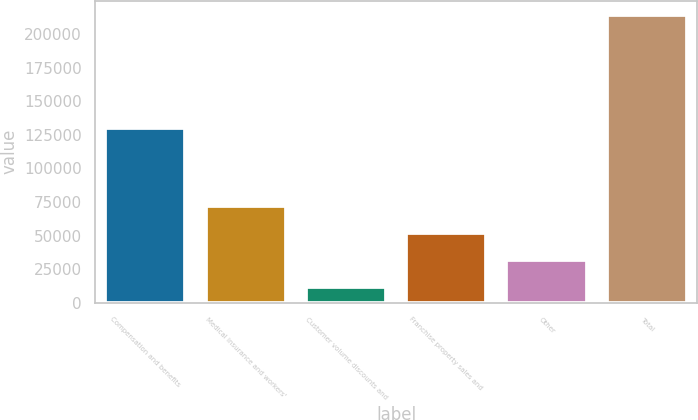<chart> <loc_0><loc_0><loc_500><loc_500><bar_chart><fcel>Compensation and benefits<fcel>Medical insurance and workers'<fcel>Customer volume discounts and<fcel>Franchise property sales and<fcel>Other<fcel>Total<nl><fcel>130455<fcel>72222.6<fcel>11436<fcel>51960.4<fcel>31698.2<fcel>214058<nl></chart> 